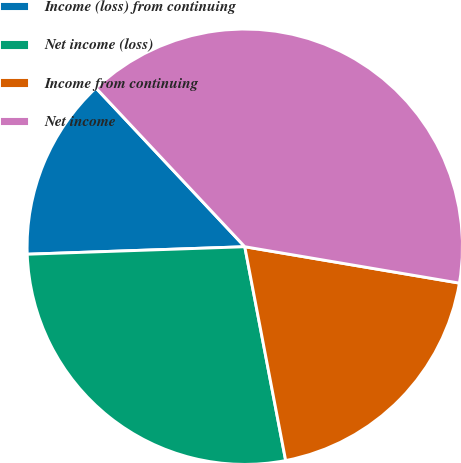Convert chart. <chart><loc_0><loc_0><loc_500><loc_500><pie_chart><fcel>Income (loss) from continuing<fcel>Net income (loss)<fcel>Income from continuing<fcel>Net income<nl><fcel>13.56%<fcel>27.46%<fcel>19.32%<fcel>39.66%<nl></chart> 